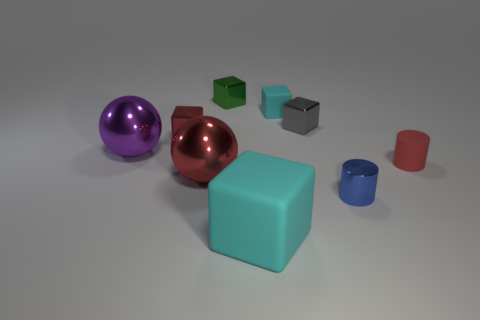What relative positions do the objects form from this perspective? From this angle, the objects form a roughly semicircular arrangement around the central blue cube. The purple and copper spheres sit to the back and slightly to the right. The two small gray cubes are in front and to the right. The red cube and tiny red cylinder are off to the left side, with the blue hollow cylinder sitting even farther to the left and slightly forward from the blue cube's face. 